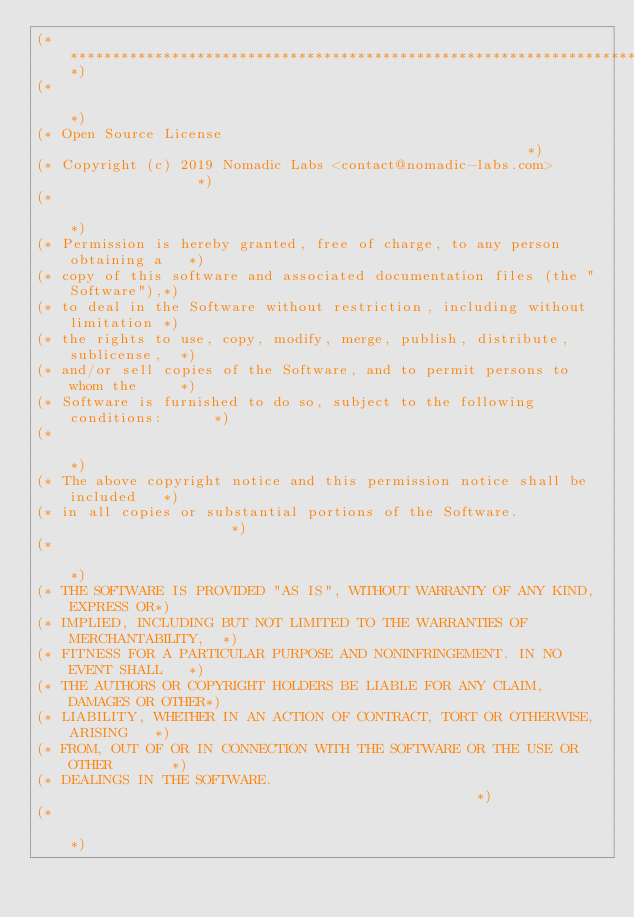<code> <loc_0><loc_0><loc_500><loc_500><_OCaml_>(*****************************************************************************)
(*                                                                           *)
(* Open Source License                                                       *)
(* Copyright (c) 2019 Nomadic Labs <contact@nomadic-labs.com>                *)
(*                                                                           *)
(* Permission is hereby granted, free of charge, to any person obtaining a   *)
(* copy of this software and associated documentation files (the "Software"),*)
(* to deal in the Software without restriction, including without limitation *)
(* the rights to use, copy, modify, merge, publish, distribute, sublicense,  *)
(* and/or sell copies of the Software, and to permit persons to whom the     *)
(* Software is furnished to do so, subject to the following conditions:      *)
(*                                                                           *)
(* The above copyright notice and this permission notice shall be included   *)
(* in all copies or substantial portions of the Software.                    *)
(*                                                                           *)
(* THE SOFTWARE IS PROVIDED "AS IS", WITHOUT WARRANTY OF ANY KIND, EXPRESS OR*)
(* IMPLIED, INCLUDING BUT NOT LIMITED TO THE WARRANTIES OF MERCHANTABILITY,  *)
(* FITNESS FOR A PARTICULAR PURPOSE AND NONINFRINGEMENT. IN NO EVENT SHALL   *)
(* THE AUTHORS OR COPYRIGHT HOLDERS BE LIABLE FOR ANY CLAIM, DAMAGES OR OTHER*)
(* LIABILITY, WHETHER IN AN ACTION OF CONTRACT, TORT OR OTHERWISE, ARISING   *)
(* FROM, OUT OF OR IN CONNECTION WITH THE SOFTWARE OR THE USE OR OTHER       *)
(* DEALINGS IN THE SOFTWARE.                                                 *)
(*                                                                           *)</code> 